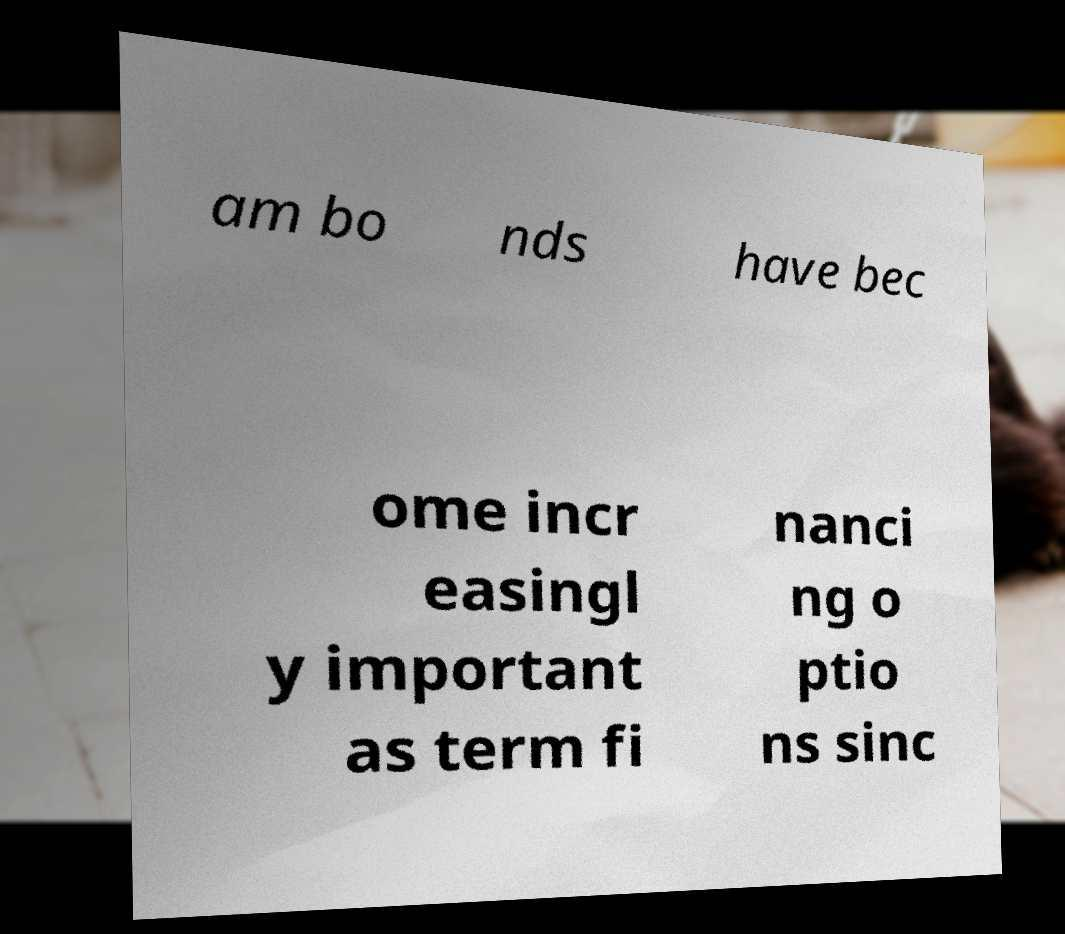Can you accurately transcribe the text from the provided image for me? am bo nds have bec ome incr easingl y important as term fi nanci ng o ptio ns sinc 